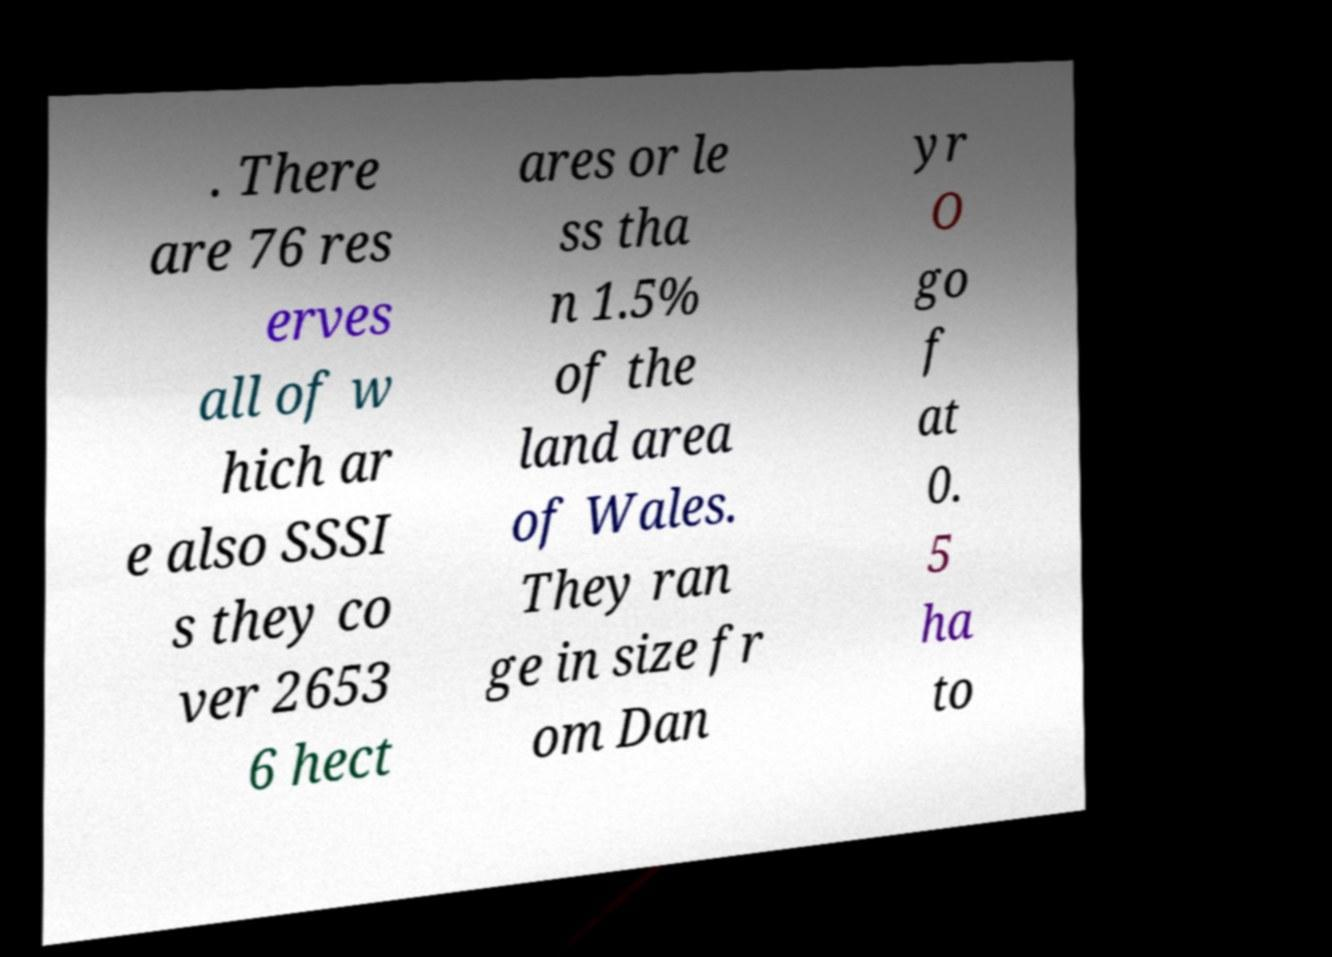Could you extract and type out the text from this image? . There are 76 res erves all of w hich ar e also SSSI s they co ver 2653 6 hect ares or le ss tha n 1.5% of the land area of Wales. They ran ge in size fr om Dan yr O go f at 0. 5 ha to 